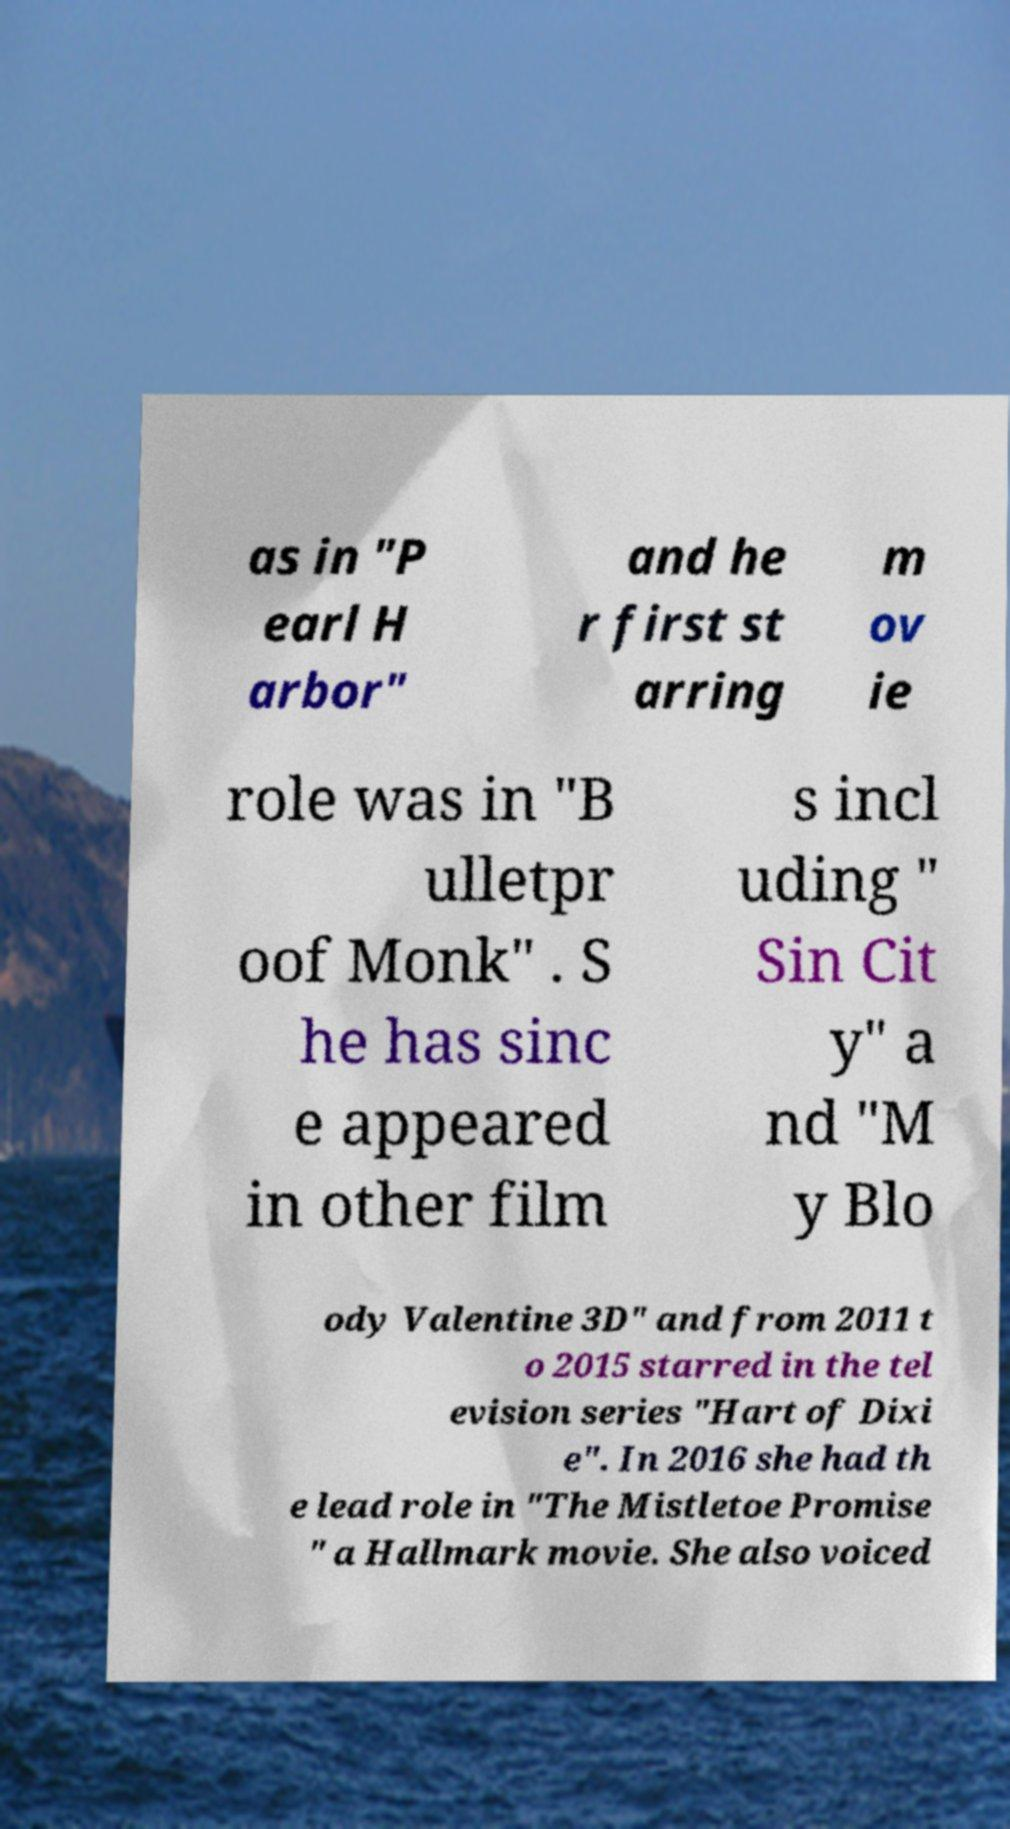Can you read and provide the text displayed in the image?This photo seems to have some interesting text. Can you extract and type it out for me? as in "P earl H arbor" and he r first st arring m ov ie role was in "B ulletpr oof Monk" . S he has sinc e appeared in other film s incl uding " Sin Cit y" a nd "M y Blo ody Valentine 3D" and from 2011 t o 2015 starred in the tel evision series "Hart of Dixi e". In 2016 she had th e lead role in "The Mistletoe Promise " a Hallmark movie. She also voiced 